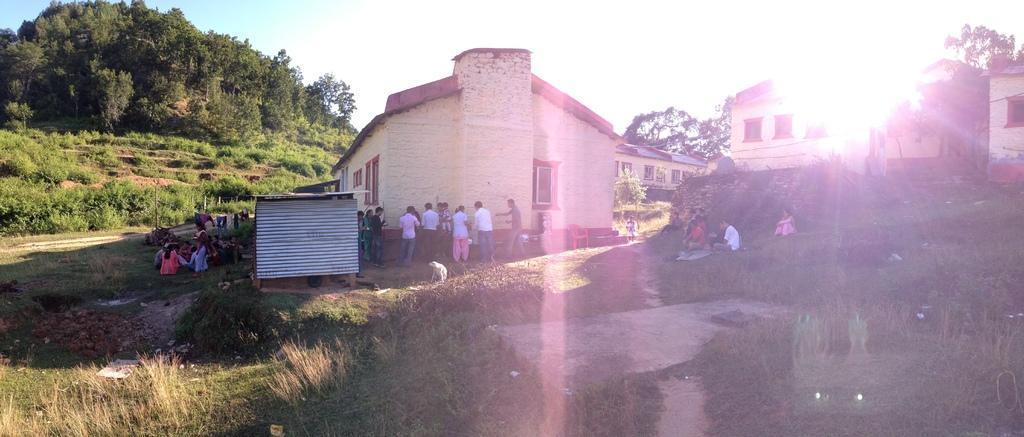How would you summarize this image in a sentence or two? At the bottom of the picture, we see the grass. In the middle, we see a shed which is made up of iron sheets. Beside that, we see the people are sitting on the grass. Behind them, we see the clothes are hanging on the rope. Beside the shed, we see the people are standing. We see a white dog. In front of them, we see a building. Beside them, we see a red chair and a man is standing. We see the people are sitting on the grass. On the right side, we see the buildings and grass. There are trees and buildings in the background. At the top, we see the sky. 